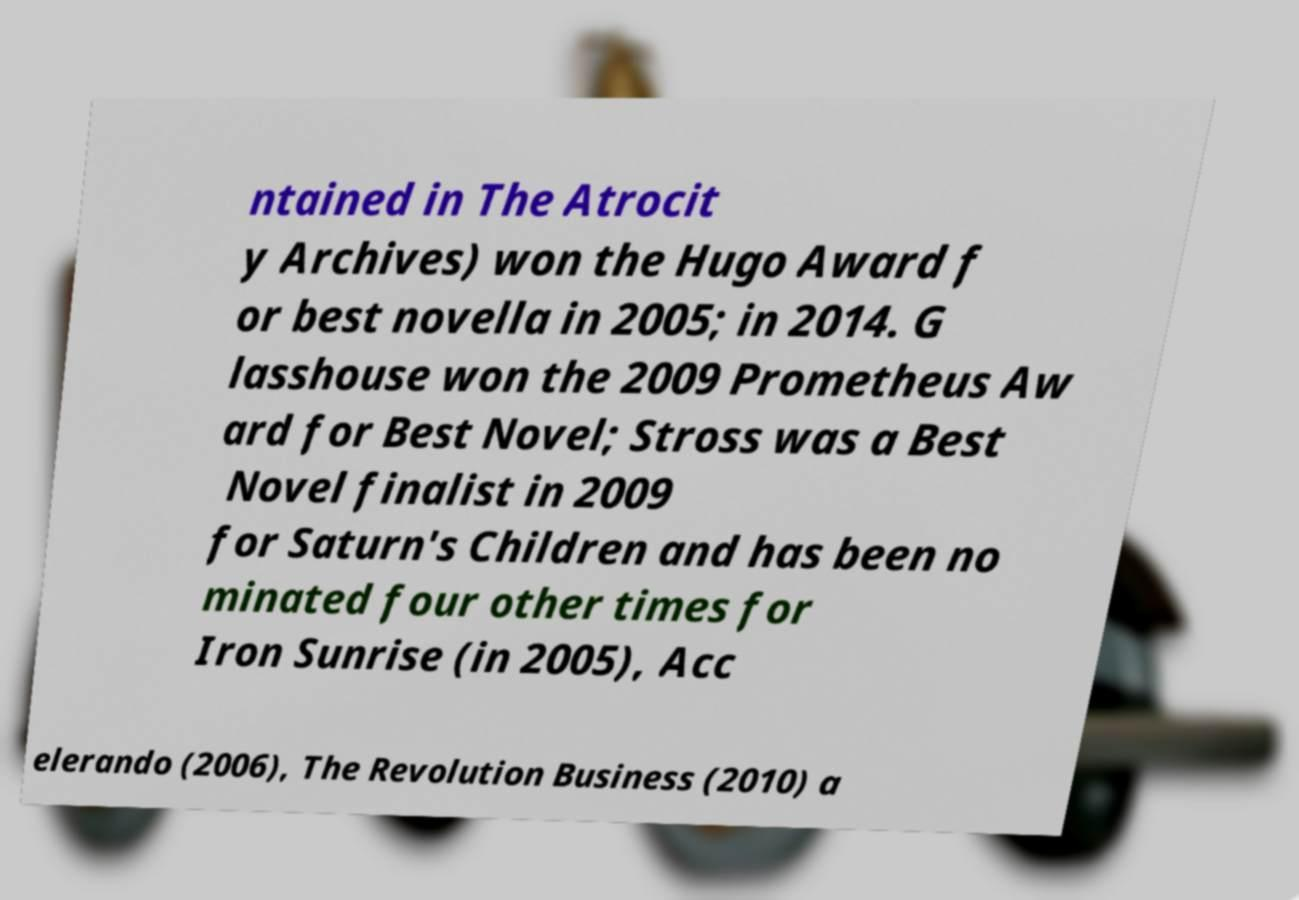There's text embedded in this image that I need extracted. Can you transcribe it verbatim? ntained in The Atrocit y Archives) won the Hugo Award f or best novella in 2005; in 2014. G lasshouse won the 2009 Prometheus Aw ard for Best Novel; Stross was a Best Novel finalist in 2009 for Saturn's Children and has been no minated four other times for Iron Sunrise (in 2005), Acc elerando (2006), The Revolution Business (2010) a 